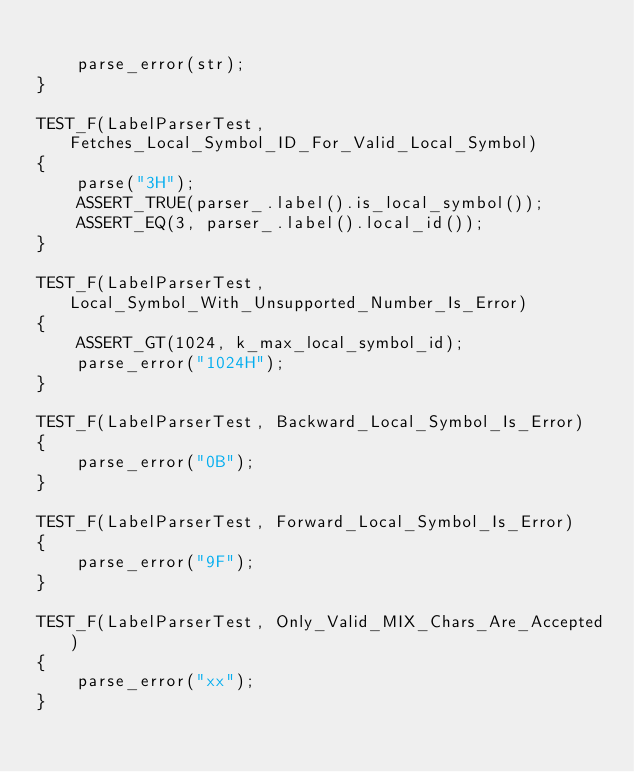<code> <loc_0><loc_0><loc_500><loc_500><_C++_>
	parse_error(str);
}

TEST_F(LabelParserTest, Fetches_Local_Symbol_ID_For_Valid_Local_Symbol)
{
	parse("3H");
	ASSERT_TRUE(parser_.label().is_local_symbol());
	ASSERT_EQ(3, parser_.label().local_id());
}

TEST_F(LabelParserTest, Local_Symbol_With_Unsupported_Number_Is_Error)
{
	ASSERT_GT(1024, k_max_local_symbol_id);
	parse_error("1024H");
}

TEST_F(LabelParserTest, Backward_Local_Symbol_Is_Error)
{
	parse_error("0B");
}

TEST_F(LabelParserTest, Forward_Local_Symbol_Is_Error)
{
	parse_error("9F");
}

TEST_F(LabelParserTest, Only_Valid_MIX_Chars_Are_Accepted)
{
	parse_error("xx");
}
</code> 